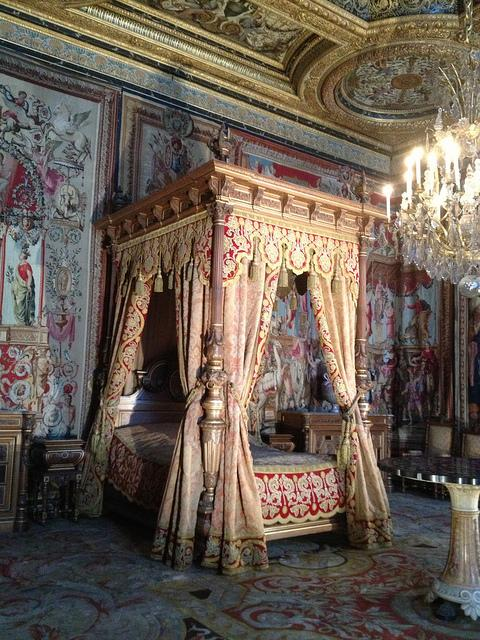What is needed to light the candles on the chandeliers? fire 